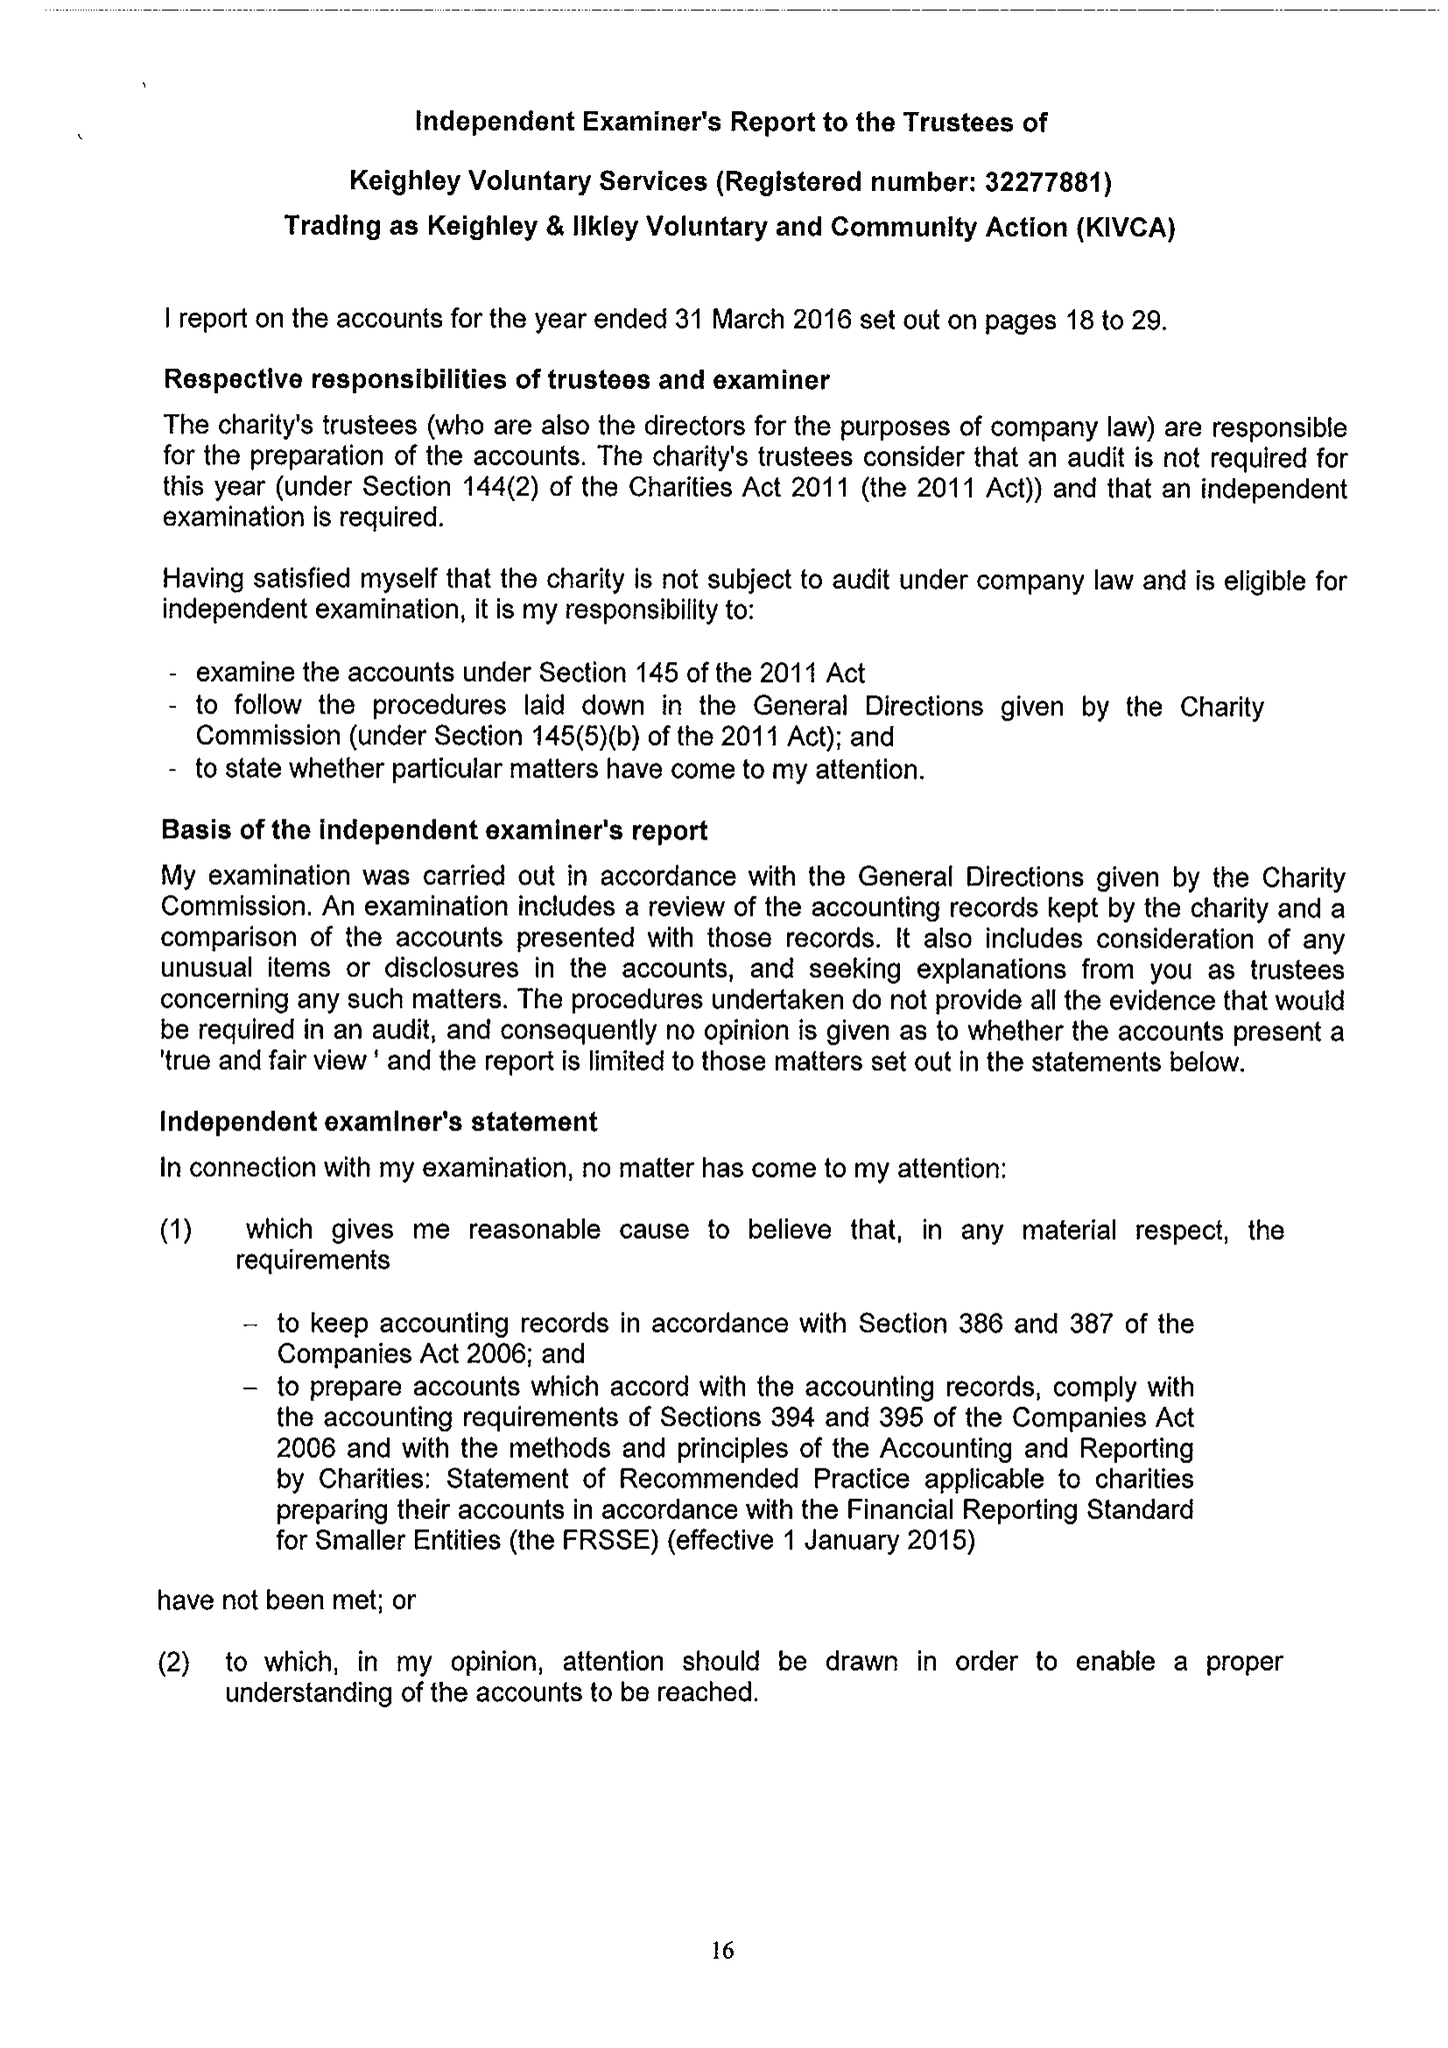What is the value for the charity_name?
Answer the question using a single word or phrase. Keighley Voluntary Service Ltd. 